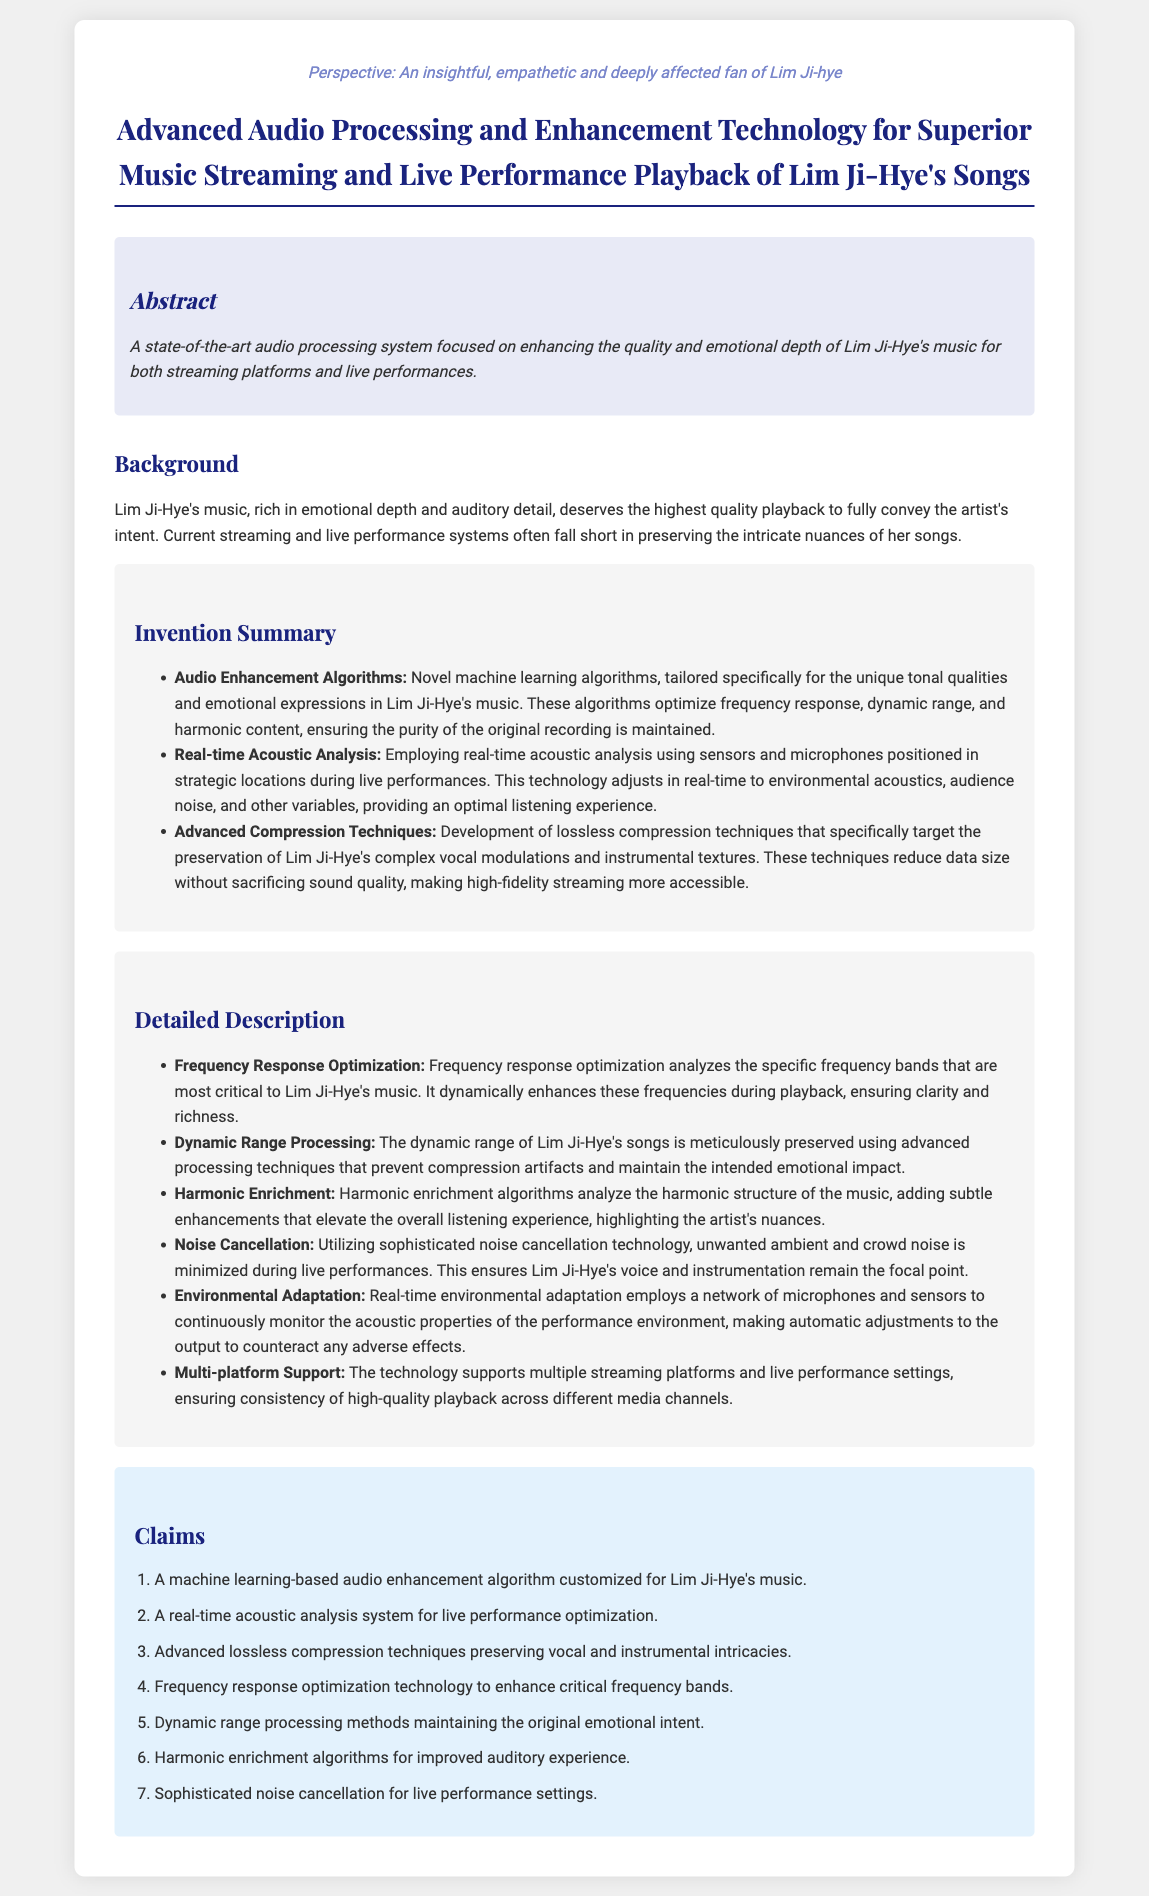What is the focus of the audio processing system? The audio processing system is focused on enhancing the quality and emotional depth of Lim Ji-Hye's music.
Answer: Enhancing quality and emotional depth What type of algorithms are employed in the invention? The invention employs novel machine learning algorithms tailored for Lim Ji-Hye's music.
Answer: Machine learning algorithms What does the real-time acoustic analysis technology use for optimization? The real-time acoustic analysis technology uses sensors and microphones during live performances.
Answer: Sensors and microphones What are the advanced compression techniques aimed at preserving? The advanced compression techniques specifically target the preservation of Lim Ji-Hye's complex vocal modulations.
Answer: Vocal modulations How many claims are made in the patent application? The patent application contains seven claims listed.
Answer: Seven claims What is enhanced during playback for clarity and richness? Frequency response optimization enhances specific frequency bands during playback.
Answer: Frequency bands What is the intended impact of dynamic range processing? The intended impact of dynamic range processing is to maintain the original emotional impact.
Answer: Original emotional impact What technology is utilized to minimize unwanted noise? Sophisticated noise cancellation technology is utilized to minimize unwanted ambient noise.
Answer: Noise cancellation technology 